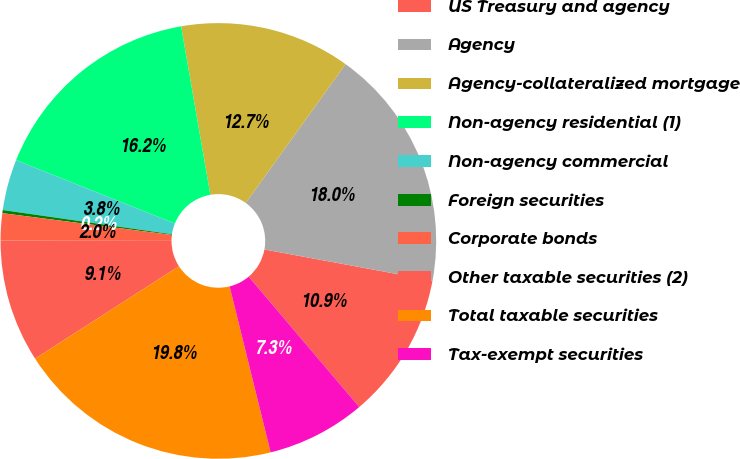Convert chart. <chart><loc_0><loc_0><loc_500><loc_500><pie_chart><fcel>US Treasury and agency<fcel>Agency<fcel>Agency-collateralized mortgage<fcel>Non-agency residential (1)<fcel>Non-agency commercial<fcel>Foreign securities<fcel>Corporate bonds<fcel>Other taxable securities (2)<fcel>Total taxable securities<fcel>Tax-exempt securities<nl><fcel>10.89%<fcel>17.99%<fcel>12.66%<fcel>16.22%<fcel>3.78%<fcel>0.23%<fcel>2.01%<fcel>9.11%<fcel>19.77%<fcel>7.34%<nl></chart> 